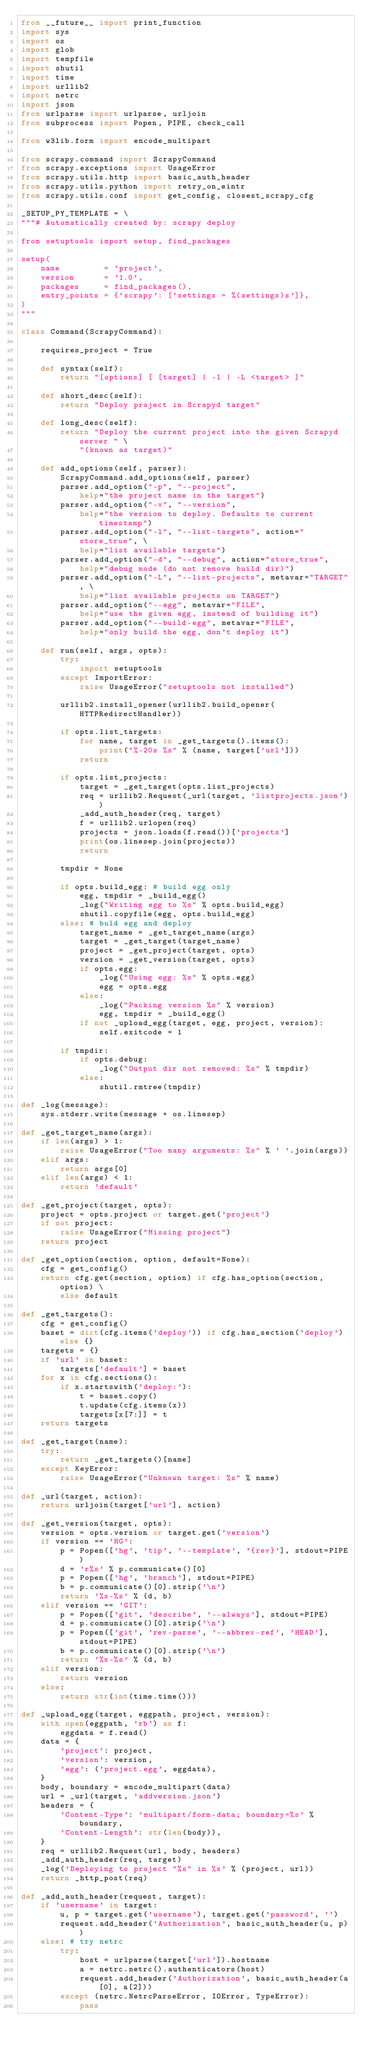<code> <loc_0><loc_0><loc_500><loc_500><_Python_>from __future__ import print_function
import sys
import os
import glob
import tempfile
import shutil
import time
import urllib2
import netrc
import json
from urlparse import urlparse, urljoin
from subprocess import Popen, PIPE, check_call

from w3lib.form import encode_multipart

from scrapy.command import ScrapyCommand
from scrapy.exceptions import UsageError
from scrapy.utils.http import basic_auth_header
from scrapy.utils.python import retry_on_eintr
from scrapy.utils.conf import get_config, closest_scrapy_cfg

_SETUP_PY_TEMPLATE = \
"""# Automatically created by: scrapy deploy

from setuptools import setup, find_packages

setup(
    name         = 'project',
    version      = '1.0',
    packages     = find_packages(),
    entry_points = {'scrapy': ['settings = %(settings)s']},
)
"""

class Command(ScrapyCommand):

    requires_project = True

    def syntax(self):
        return "[options] [ [target] | -l | -L <target> ]"

    def short_desc(self):
        return "Deploy project in Scrapyd target"

    def long_desc(self):
        return "Deploy the current project into the given Scrapyd server " \
            "(known as target)"

    def add_options(self, parser):
        ScrapyCommand.add_options(self, parser)
        parser.add_option("-p", "--project",
            help="the project name in the target")
        parser.add_option("-v", "--version",
            help="the version to deploy. Defaults to current timestamp")
        parser.add_option("-l", "--list-targets", action="store_true", \
            help="list available targets")
        parser.add_option("-d", "--debug", action="store_true",
            help="debug mode (do not remove build dir)")
        parser.add_option("-L", "--list-projects", metavar="TARGET", \
            help="list available projects on TARGET")
        parser.add_option("--egg", metavar="FILE",
            help="use the given egg, instead of building it")
        parser.add_option("--build-egg", metavar="FILE",
            help="only build the egg, don't deploy it")

    def run(self, args, opts):
        try:
            import setuptools
        except ImportError:
            raise UsageError("setuptools not installed")

        urllib2.install_opener(urllib2.build_opener(HTTPRedirectHandler))

        if opts.list_targets:
            for name, target in _get_targets().items():
                print("%-20s %s" % (name, target['url']))
            return

        if opts.list_projects:
            target = _get_target(opts.list_projects)
            req = urllib2.Request(_url(target, 'listprojects.json'))
            _add_auth_header(req, target)
            f = urllib2.urlopen(req)
            projects = json.loads(f.read())['projects']
            print(os.linesep.join(projects))
            return

        tmpdir = None

        if opts.build_egg: # build egg only
            egg, tmpdir = _build_egg()
            _log("Writing egg to %s" % opts.build_egg)
            shutil.copyfile(egg, opts.build_egg)
        else: # buld egg and deploy
            target_name = _get_target_name(args)
            target = _get_target(target_name)
            project = _get_project(target, opts)
            version = _get_version(target, opts)
            if opts.egg:
                _log("Using egg: %s" % opts.egg)
                egg = opts.egg
            else:
                _log("Packing version %s" % version)
                egg, tmpdir = _build_egg()
            if not _upload_egg(target, egg, project, version):
                self.exitcode = 1

        if tmpdir:
            if opts.debug:
                _log("Output dir not removed: %s" % tmpdir)
            else:
                shutil.rmtree(tmpdir)

def _log(message):
    sys.stderr.write(message + os.linesep)

def _get_target_name(args):
    if len(args) > 1:
        raise UsageError("Too many arguments: %s" % ' '.join(args))
    elif args:
        return args[0]
    elif len(args) < 1:
        return 'default'

def _get_project(target, opts):
    project = opts.project or target.get('project')
    if not project:
        raise UsageError("Missing project")
    return project

def _get_option(section, option, default=None):
    cfg = get_config()
    return cfg.get(section, option) if cfg.has_option(section, option) \
        else default

def _get_targets():
    cfg = get_config()
    baset = dict(cfg.items('deploy')) if cfg.has_section('deploy') else {}
    targets = {}
    if 'url' in baset:
        targets['default'] = baset
    for x in cfg.sections():
        if x.startswith('deploy:'):
            t = baset.copy()
            t.update(cfg.items(x))
            targets[x[7:]] = t
    return targets

def _get_target(name):
    try:
        return _get_targets()[name]
    except KeyError:
        raise UsageError("Unknown target: %s" % name)

def _url(target, action):
    return urljoin(target['url'], action)

def _get_version(target, opts):
    version = opts.version or target.get('version')
    if version == 'HG':
        p = Popen(['hg', 'tip', '--template', '{rev}'], stdout=PIPE)
        d = 'r%s' % p.communicate()[0]
        p = Popen(['hg', 'branch'], stdout=PIPE)
        b = p.communicate()[0].strip('\n')
        return '%s-%s' % (d, b)
    elif version == 'GIT':
        p = Popen(['git', 'describe', '--always'], stdout=PIPE)
        d = p.communicate()[0].strip('\n')
        p = Popen(['git', 'rev-parse', '--abbrev-ref', 'HEAD'], stdout=PIPE)
        b = p.communicate()[0].strip('\n')
        return '%s-%s' % (d, b)
    elif version:
        return version
    else:
        return str(int(time.time()))

def _upload_egg(target, eggpath, project, version):
    with open(eggpath, 'rb') as f:
        eggdata = f.read()
    data = {
        'project': project,
        'version': version,
        'egg': ('project.egg', eggdata),
    }
    body, boundary = encode_multipart(data)
    url = _url(target, 'addversion.json')
    headers = {
        'Content-Type': 'multipart/form-data; boundary=%s' % boundary,
        'Content-Length': str(len(body)),
    }
    req = urllib2.Request(url, body, headers)
    _add_auth_header(req, target)
    _log('Deploying to project "%s" in %s' % (project, url))
    return _http_post(req)

def _add_auth_header(request, target):
    if 'username' in target:
        u, p = target.get('username'), target.get('password', '')
        request.add_header('Authorization', basic_auth_header(u, p))
    else: # try netrc
        try:
            host = urlparse(target['url']).hostname
            a = netrc.netrc().authenticators(host)
            request.add_header('Authorization', basic_auth_header(a[0], a[2]))
        except (netrc.NetrcParseError, IOError, TypeError):
            pass
</code> 